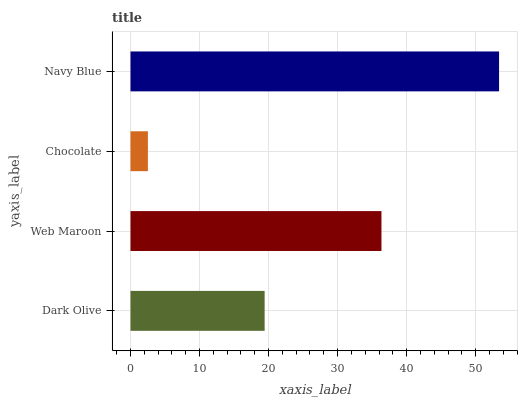Is Chocolate the minimum?
Answer yes or no. Yes. Is Navy Blue the maximum?
Answer yes or no. Yes. Is Web Maroon the minimum?
Answer yes or no. No. Is Web Maroon the maximum?
Answer yes or no. No. Is Web Maroon greater than Dark Olive?
Answer yes or no. Yes. Is Dark Olive less than Web Maroon?
Answer yes or no. Yes. Is Dark Olive greater than Web Maroon?
Answer yes or no. No. Is Web Maroon less than Dark Olive?
Answer yes or no. No. Is Web Maroon the high median?
Answer yes or no. Yes. Is Dark Olive the low median?
Answer yes or no. Yes. Is Dark Olive the high median?
Answer yes or no. No. Is Chocolate the low median?
Answer yes or no. No. 